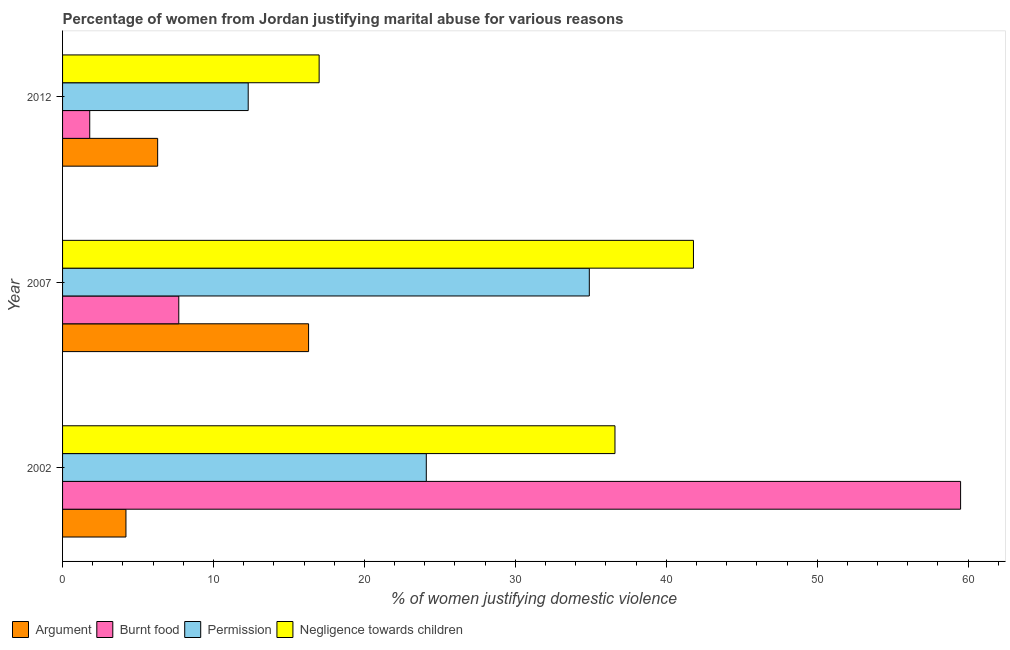How many groups of bars are there?
Ensure brevity in your answer.  3. Are the number of bars per tick equal to the number of legend labels?
Provide a short and direct response. Yes. What is the label of the 2nd group of bars from the top?
Give a very brief answer. 2007. In how many cases, is the number of bars for a given year not equal to the number of legend labels?
Ensure brevity in your answer.  0. Across all years, what is the maximum percentage of women justifying abuse for showing negligence towards children?
Provide a short and direct response. 41.8. In which year was the percentage of women justifying abuse in the case of an argument maximum?
Your answer should be compact. 2007. In which year was the percentage of women justifying abuse in the case of an argument minimum?
Your response must be concise. 2002. What is the total percentage of women justifying abuse for going without permission in the graph?
Your answer should be very brief. 71.3. What is the difference between the percentage of women justifying abuse for burning food in 2007 and that in 2012?
Your answer should be very brief. 5.9. What is the difference between the percentage of women justifying abuse for going without permission in 2012 and the percentage of women justifying abuse for burning food in 2002?
Give a very brief answer. -47.2. What is the average percentage of women justifying abuse for showing negligence towards children per year?
Your answer should be compact. 31.8. In the year 2012, what is the difference between the percentage of women justifying abuse for going without permission and percentage of women justifying abuse in the case of an argument?
Ensure brevity in your answer.  6. What is the ratio of the percentage of women justifying abuse in the case of an argument in 2007 to that in 2012?
Offer a terse response. 2.59. What is the difference between the highest and the lowest percentage of women justifying abuse for burning food?
Your answer should be very brief. 57.7. In how many years, is the percentage of women justifying abuse for going without permission greater than the average percentage of women justifying abuse for going without permission taken over all years?
Make the answer very short. 2. Is the sum of the percentage of women justifying abuse for burning food in 2007 and 2012 greater than the maximum percentage of women justifying abuse in the case of an argument across all years?
Offer a very short reply. No. What does the 3rd bar from the top in 2012 represents?
Keep it short and to the point. Burnt food. What does the 2nd bar from the bottom in 2012 represents?
Give a very brief answer. Burnt food. How many years are there in the graph?
Your response must be concise. 3. Are the values on the major ticks of X-axis written in scientific E-notation?
Provide a succinct answer. No. Does the graph contain any zero values?
Provide a short and direct response. No. How are the legend labels stacked?
Provide a succinct answer. Horizontal. What is the title of the graph?
Your answer should be compact. Percentage of women from Jordan justifying marital abuse for various reasons. Does "Macroeconomic management" appear as one of the legend labels in the graph?
Your answer should be compact. No. What is the label or title of the X-axis?
Offer a very short reply. % of women justifying domestic violence. What is the label or title of the Y-axis?
Provide a short and direct response. Year. What is the % of women justifying domestic violence in Burnt food in 2002?
Give a very brief answer. 59.5. What is the % of women justifying domestic violence of Permission in 2002?
Make the answer very short. 24.1. What is the % of women justifying domestic violence in Negligence towards children in 2002?
Your response must be concise. 36.6. What is the % of women justifying domestic violence in Argument in 2007?
Offer a very short reply. 16.3. What is the % of women justifying domestic violence in Burnt food in 2007?
Offer a terse response. 7.7. What is the % of women justifying domestic violence in Permission in 2007?
Your answer should be compact. 34.9. What is the % of women justifying domestic violence in Negligence towards children in 2007?
Your response must be concise. 41.8. What is the % of women justifying domestic violence of Burnt food in 2012?
Keep it short and to the point. 1.8. What is the % of women justifying domestic violence of Permission in 2012?
Keep it short and to the point. 12.3. What is the % of women justifying domestic violence of Negligence towards children in 2012?
Give a very brief answer. 17. Across all years, what is the maximum % of women justifying domestic violence of Burnt food?
Your response must be concise. 59.5. Across all years, what is the maximum % of women justifying domestic violence of Permission?
Make the answer very short. 34.9. Across all years, what is the maximum % of women justifying domestic violence in Negligence towards children?
Ensure brevity in your answer.  41.8. Across all years, what is the minimum % of women justifying domestic violence of Permission?
Give a very brief answer. 12.3. Across all years, what is the minimum % of women justifying domestic violence in Negligence towards children?
Your answer should be very brief. 17. What is the total % of women justifying domestic violence in Argument in the graph?
Your answer should be very brief. 26.8. What is the total % of women justifying domestic violence in Burnt food in the graph?
Offer a very short reply. 69. What is the total % of women justifying domestic violence of Permission in the graph?
Provide a succinct answer. 71.3. What is the total % of women justifying domestic violence in Negligence towards children in the graph?
Keep it short and to the point. 95.4. What is the difference between the % of women justifying domestic violence of Argument in 2002 and that in 2007?
Your answer should be very brief. -12.1. What is the difference between the % of women justifying domestic violence of Burnt food in 2002 and that in 2007?
Provide a short and direct response. 51.8. What is the difference between the % of women justifying domestic violence in Burnt food in 2002 and that in 2012?
Your answer should be very brief. 57.7. What is the difference between the % of women justifying domestic violence of Negligence towards children in 2002 and that in 2012?
Your answer should be very brief. 19.6. What is the difference between the % of women justifying domestic violence in Argument in 2007 and that in 2012?
Your answer should be very brief. 10. What is the difference between the % of women justifying domestic violence in Burnt food in 2007 and that in 2012?
Ensure brevity in your answer.  5.9. What is the difference between the % of women justifying domestic violence in Permission in 2007 and that in 2012?
Offer a terse response. 22.6. What is the difference between the % of women justifying domestic violence of Negligence towards children in 2007 and that in 2012?
Offer a terse response. 24.8. What is the difference between the % of women justifying domestic violence in Argument in 2002 and the % of women justifying domestic violence in Permission in 2007?
Your answer should be compact. -30.7. What is the difference between the % of women justifying domestic violence in Argument in 2002 and the % of women justifying domestic violence in Negligence towards children in 2007?
Keep it short and to the point. -37.6. What is the difference between the % of women justifying domestic violence of Burnt food in 2002 and the % of women justifying domestic violence of Permission in 2007?
Your answer should be compact. 24.6. What is the difference between the % of women justifying domestic violence in Burnt food in 2002 and the % of women justifying domestic violence in Negligence towards children in 2007?
Provide a short and direct response. 17.7. What is the difference between the % of women justifying domestic violence in Permission in 2002 and the % of women justifying domestic violence in Negligence towards children in 2007?
Provide a succinct answer. -17.7. What is the difference between the % of women justifying domestic violence in Argument in 2002 and the % of women justifying domestic violence in Permission in 2012?
Your answer should be very brief. -8.1. What is the difference between the % of women justifying domestic violence of Argument in 2002 and the % of women justifying domestic violence of Negligence towards children in 2012?
Your answer should be compact. -12.8. What is the difference between the % of women justifying domestic violence of Burnt food in 2002 and the % of women justifying domestic violence of Permission in 2012?
Ensure brevity in your answer.  47.2. What is the difference between the % of women justifying domestic violence in Burnt food in 2002 and the % of women justifying domestic violence in Negligence towards children in 2012?
Make the answer very short. 42.5. What is the difference between the % of women justifying domestic violence of Permission in 2002 and the % of women justifying domestic violence of Negligence towards children in 2012?
Make the answer very short. 7.1. What is the difference between the % of women justifying domestic violence in Argument in 2007 and the % of women justifying domestic violence in Burnt food in 2012?
Provide a short and direct response. 14.5. What is the difference between the % of women justifying domestic violence of Argument in 2007 and the % of women justifying domestic violence of Negligence towards children in 2012?
Your answer should be compact. -0.7. What is the difference between the % of women justifying domestic violence in Burnt food in 2007 and the % of women justifying domestic violence in Negligence towards children in 2012?
Keep it short and to the point. -9.3. What is the difference between the % of women justifying domestic violence of Permission in 2007 and the % of women justifying domestic violence of Negligence towards children in 2012?
Your answer should be very brief. 17.9. What is the average % of women justifying domestic violence of Argument per year?
Offer a terse response. 8.93. What is the average % of women justifying domestic violence in Burnt food per year?
Keep it short and to the point. 23. What is the average % of women justifying domestic violence of Permission per year?
Give a very brief answer. 23.77. What is the average % of women justifying domestic violence in Negligence towards children per year?
Your response must be concise. 31.8. In the year 2002, what is the difference between the % of women justifying domestic violence of Argument and % of women justifying domestic violence of Burnt food?
Your response must be concise. -55.3. In the year 2002, what is the difference between the % of women justifying domestic violence of Argument and % of women justifying domestic violence of Permission?
Keep it short and to the point. -19.9. In the year 2002, what is the difference between the % of women justifying domestic violence in Argument and % of women justifying domestic violence in Negligence towards children?
Your answer should be very brief. -32.4. In the year 2002, what is the difference between the % of women justifying domestic violence of Burnt food and % of women justifying domestic violence of Permission?
Offer a very short reply. 35.4. In the year 2002, what is the difference between the % of women justifying domestic violence in Burnt food and % of women justifying domestic violence in Negligence towards children?
Ensure brevity in your answer.  22.9. In the year 2002, what is the difference between the % of women justifying domestic violence in Permission and % of women justifying domestic violence in Negligence towards children?
Offer a terse response. -12.5. In the year 2007, what is the difference between the % of women justifying domestic violence of Argument and % of women justifying domestic violence of Permission?
Your response must be concise. -18.6. In the year 2007, what is the difference between the % of women justifying domestic violence of Argument and % of women justifying domestic violence of Negligence towards children?
Offer a terse response. -25.5. In the year 2007, what is the difference between the % of women justifying domestic violence of Burnt food and % of women justifying domestic violence of Permission?
Give a very brief answer. -27.2. In the year 2007, what is the difference between the % of women justifying domestic violence of Burnt food and % of women justifying domestic violence of Negligence towards children?
Your answer should be compact. -34.1. In the year 2007, what is the difference between the % of women justifying domestic violence of Permission and % of women justifying domestic violence of Negligence towards children?
Your answer should be compact. -6.9. In the year 2012, what is the difference between the % of women justifying domestic violence of Argument and % of women justifying domestic violence of Permission?
Your answer should be compact. -6. In the year 2012, what is the difference between the % of women justifying domestic violence of Burnt food and % of women justifying domestic violence of Negligence towards children?
Ensure brevity in your answer.  -15.2. In the year 2012, what is the difference between the % of women justifying domestic violence in Permission and % of women justifying domestic violence in Negligence towards children?
Keep it short and to the point. -4.7. What is the ratio of the % of women justifying domestic violence in Argument in 2002 to that in 2007?
Your response must be concise. 0.26. What is the ratio of the % of women justifying domestic violence of Burnt food in 2002 to that in 2007?
Offer a very short reply. 7.73. What is the ratio of the % of women justifying domestic violence in Permission in 2002 to that in 2007?
Your response must be concise. 0.69. What is the ratio of the % of women justifying domestic violence of Negligence towards children in 2002 to that in 2007?
Provide a short and direct response. 0.88. What is the ratio of the % of women justifying domestic violence in Burnt food in 2002 to that in 2012?
Your answer should be compact. 33.06. What is the ratio of the % of women justifying domestic violence in Permission in 2002 to that in 2012?
Your answer should be compact. 1.96. What is the ratio of the % of women justifying domestic violence in Negligence towards children in 2002 to that in 2012?
Provide a succinct answer. 2.15. What is the ratio of the % of women justifying domestic violence of Argument in 2007 to that in 2012?
Ensure brevity in your answer.  2.59. What is the ratio of the % of women justifying domestic violence of Burnt food in 2007 to that in 2012?
Your answer should be very brief. 4.28. What is the ratio of the % of women justifying domestic violence in Permission in 2007 to that in 2012?
Give a very brief answer. 2.84. What is the ratio of the % of women justifying domestic violence of Negligence towards children in 2007 to that in 2012?
Your answer should be compact. 2.46. What is the difference between the highest and the second highest % of women justifying domestic violence in Argument?
Your answer should be very brief. 10. What is the difference between the highest and the second highest % of women justifying domestic violence of Burnt food?
Provide a succinct answer. 51.8. What is the difference between the highest and the second highest % of women justifying domestic violence of Permission?
Your answer should be very brief. 10.8. What is the difference between the highest and the second highest % of women justifying domestic violence in Negligence towards children?
Provide a succinct answer. 5.2. What is the difference between the highest and the lowest % of women justifying domestic violence of Argument?
Offer a terse response. 12.1. What is the difference between the highest and the lowest % of women justifying domestic violence of Burnt food?
Your answer should be compact. 57.7. What is the difference between the highest and the lowest % of women justifying domestic violence of Permission?
Offer a very short reply. 22.6. What is the difference between the highest and the lowest % of women justifying domestic violence of Negligence towards children?
Your response must be concise. 24.8. 